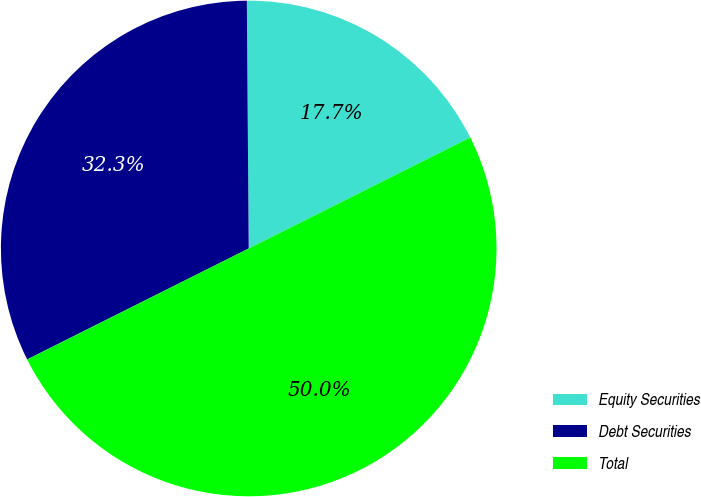<chart> <loc_0><loc_0><loc_500><loc_500><pie_chart><fcel>Equity Securities<fcel>Debt Securities<fcel>Total<nl><fcel>17.73%<fcel>32.27%<fcel>50.0%<nl></chart> 